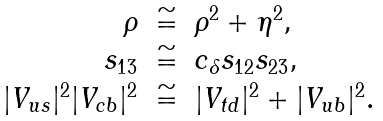<formula> <loc_0><loc_0><loc_500><loc_500>\begin{array} { r c l } \rho & \cong & \rho ^ { 2 } + \eta ^ { 2 } , \\ s _ { 1 3 } & \cong & c _ { \delta } s _ { 1 2 } s _ { 2 3 } , \\ | V _ { u s } | ^ { 2 } | V _ { c b } | ^ { 2 } & \cong & | V _ { t d } | ^ { 2 } + | V _ { u b } | ^ { 2 } . \end{array}</formula> 